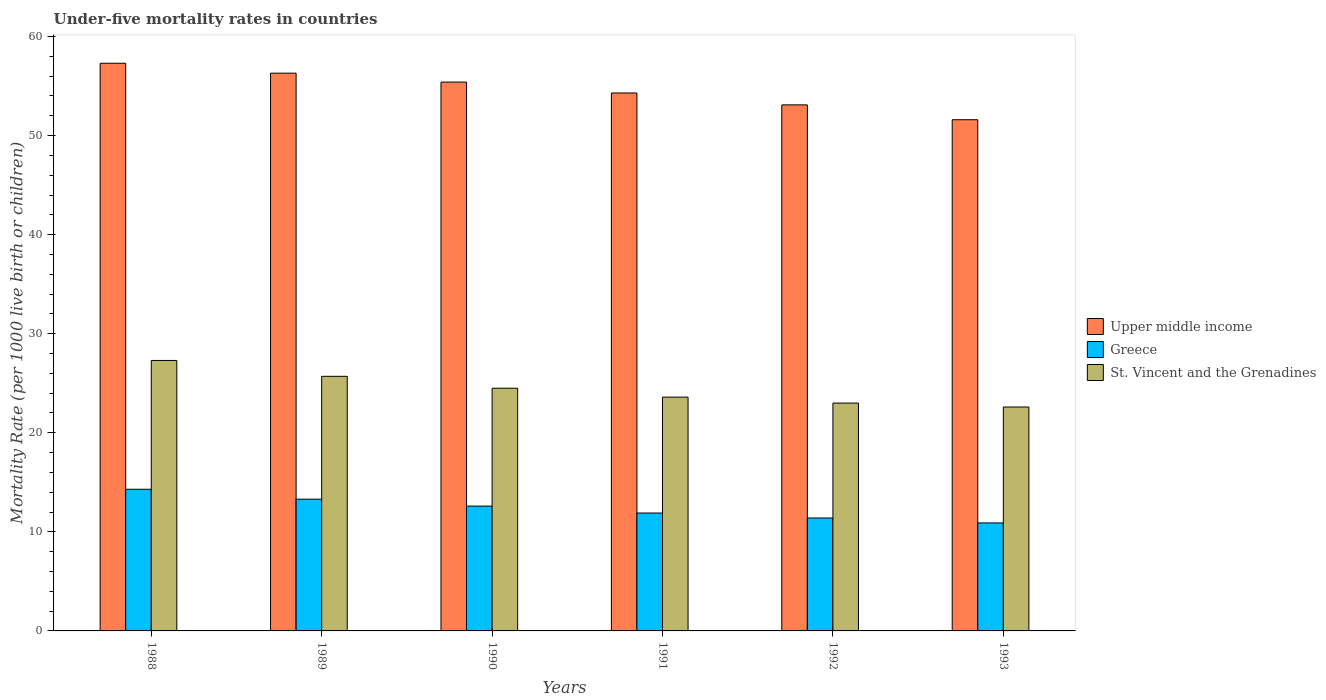How many different coloured bars are there?
Give a very brief answer. 3. How many groups of bars are there?
Your answer should be compact. 6. Are the number of bars on each tick of the X-axis equal?
Make the answer very short. Yes. What is the under-five mortality rate in Upper middle income in 1993?
Your answer should be very brief. 51.6. Across all years, what is the maximum under-five mortality rate in St. Vincent and the Grenadines?
Give a very brief answer. 27.3. Across all years, what is the minimum under-five mortality rate in St. Vincent and the Grenadines?
Provide a short and direct response. 22.6. In which year was the under-five mortality rate in St. Vincent and the Grenadines maximum?
Provide a succinct answer. 1988. In which year was the under-five mortality rate in St. Vincent and the Grenadines minimum?
Your answer should be very brief. 1993. What is the total under-five mortality rate in Greece in the graph?
Your answer should be very brief. 74.4. What is the difference between the under-five mortality rate in St. Vincent and the Grenadines in 1990 and that in 1991?
Ensure brevity in your answer.  0.9. What is the difference between the under-five mortality rate in St. Vincent and the Grenadines in 1991 and the under-five mortality rate in Greece in 1990?
Give a very brief answer. 11. What is the average under-five mortality rate in St. Vincent and the Grenadines per year?
Offer a terse response. 24.45. In how many years, is the under-five mortality rate in St. Vincent and the Grenadines greater than 20?
Ensure brevity in your answer.  6. What is the ratio of the under-five mortality rate in Upper middle income in 1988 to that in 1992?
Provide a succinct answer. 1.08. What is the difference between the highest and the lowest under-five mortality rate in Greece?
Your answer should be very brief. 3.4. What does the 3rd bar from the left in 1990 represents?
Your answer should be very brief. St. Vincent and the Grenadines. What does the 3rd bar from the right in 1990 represents?
Your response must be concise. Upper middle income. How many bars are there?
Your answer should be very brief. 18. How many years are there in the graph?
Your answer should be compact. 6. Does the graph contain grids?
Provide a short and direct response. No. What is the title of the graph?
Offer a very short reply. Under-five mortality rates in countries. Does "Burundi" appear as one of the legend labels in the graph?
Your answer should be very brief. No. What is the label or title of the Y-axis?
Provide a succinct answer. Mortality Rate (per 1000 live birth or children). What is the Mortality Rate (per 1000 live birth or children) of Upper middle income in 1988?
Your response must be concise. 57.3. What is the Mortality Rate (per 1000 live birth or children) of Greece in 1988?
Make the answer very short. 14.3. What is the Mortality Rate (per 1000 live birth or children) of St. Vincent and the Grenadines in 1988?
Give a very brief answer. 27.3. What is the Mortality Rate (per 1000 live birth or children) in Upper middle income in 1989?
Provide a short and direct response. 56.3. What is the Mortality Rate (per 1000 live birth or children) in Greece in 1989?
Give a very brief answer. 13.3. What is the Mortality Rate (per 1000 live birth or children) of St. Vincent and the Grenadines in 1989?
Your response must be concise. 25.7. What is the Mortality Rate (per 1000 live birth or children) of Upper middle income in 1990?
Your answer should be compact. 55.4. What is the Mortality Rate (per 1000 live birth or children) in St. Vincent and the Grenadines in 1990?
Provide a succinct answer. 24.5. What is the Mortality Rate (per 1000 live birth or children) of Upper middle income in 1991?
Offer a terse response. 54.3. What is the Mortality Rate (per 1000 live birth or children) of Greece in 1991?
Provide a succinct answer. 11.9. What is the Mortality Rate (per 1000 live birth or children) of St. Vincent and the Grenadines in 1991?
Provide a short and direct response. 23.6. What is the Mortality Rate (per 1000 live birth or children) of Upper middle income in 1992?
Offer a very short reply. 53.1. What is the Mortality Rate (per 1000 live birth or children) in St. Vincent and the Grenadines in 1992?
Your response must be concise. 23. What is the Mortality Rate (per 1000 live birth or children) of Upper middle income in 1993?
Provide a succinct answer. 51.6. What is the Mortality Rate (per 1000 live birth or children) of St. Vincent and the Grenadines in 1993?
Keep it short and to the point. 22.6. Across all years, what is the maximum Mortality Rate (per 1000 live birth or children) in Upper middle income?
Keep it short and to the point. 57.3. Across all years, what is the maximum Mortality Rate (per 1000 live birth or children) in St. Vincent and the Grenadines?
Your answer should be compact. 27.3. Across all years, what is the minimum Mortality Rate (per 1000 live birth or children) of Upper middle income?
Provide a succinct answer. 51.6. Across all years, what is the minimum Mortality Rate (per 1000 live birth or children) of Greece?
Offer a very short reply. 10.9. Across all years, what is the minimum Mortality Rate (per 1000 live birth or children) in St. Vincent and the Grenadines?
Your answer should be compact. 22.6. What is the total Mortality Rate (per 1000 live birth or children) in Upper middle income in the graph?
Give a very brief answer. 328. What is the total Mortality Rate (per 1000 live birth or children) of Greece in the graph?
Your response must be concise. 74.4. What is the total Mortality Rate (per 1000 live birth or children) in St. Vincent and the Grenadines in the graph?
Make the answer very short. 146.7. What is the difference between the Mortality Rate (per 1000 live birth or children) of Greece in 1988 and that in 1989?
Your response must be concise. 1. What is the difference between the Mortality Rate (per 1000 live birth or children) of St. Vincent and the Grenadines in 1988 and that in 1989?
Your answer should be very brief. 1.6. What is the difference between the Mortality Rate (per 1000 live birth or children) in Upper middle income in 1988 and that in 1990?
Make the answer very short. 1.9. What is the difference between the Mortality Rate (per 1000 live birth or children) in Upper middle income in 1988 and that in 1991?
Your answer should be compact. 3. What is the difference between the Mortality Rate (per 1000 live birth or children) of Greece in 1988 and that in 1991?
Provide a short and direct response. 2.4. What is the difference between the Mortality Rate (per 1000 live birth or children) in Greece in 1988 and that in 1992?
Your response must be concise. 2.9. What is the difference between the Mortality Rate (per 1000 live birth or children) in St. Vincent and the Grenadines in 1988 and that in 1992?
Offer a very short reply. 4.3. What is the difference between the Mortality Rate (per 1000 live birth or children) of Upper middle income in 1988 and that in 1993?
Ensure brevity in your answer.  5.7. What is the difference between the Mortality Rate (per 1000 live birth or children) of Greece in 1988 and that in 1993?
Your response must be concise. 3.4. What is the difference between the Mortality Rate (per 1000 live birth or children) of St. Vincent and the Grenadines in 1988 and that in 1993?
Provide a succinct answer. 4.7. What is the difference between the Mortality Rate (per 1000 live birth or children) in Upper middle income in 1989 and that in 1990?
Offer a terse response. 0.9. What is the difference between the Mortality Rate (per 1000 live birth or children) in Greece in 1989 and that in 1990?
Ensure brevity in your answer.  0.7. What is the difference between the Mortality Rate (per 1000 live birth or children) of Greece in 1989 and that in 1991?
Keep it short and to the point. 1.4. What is the difference between the Mortality Rate (per 1000 live birth or children) of Upper middle income in 1989 and that in 1993?
Your answer should be compact. 4.7. What is the difference between the Mortality Rate (per 1000 live birth or children) of Greece in 1989 and that in 1993?
Keep it short and to the point. 2.4. What is the difference between the Mortality Rate (per 1000 live birth or children) of St. Vincent and the Grenadines in 1989 and that in 1993?
Your response must be concise. 3.1. What is the difference between the Mortality Rate (per 1000 live birth or children) in Upper middle income in 1990 and that in 1991?
Make the answer very short. 1.1. What is the difference between the Mortality Rate (per 1000 live birth or children) in Greece in 1990 and that in 1991?
Give a very brief answer. 0.7. What is the difference between the Mortality Rate (per 1000 live birth or children) of Upper middle income in 1990 and that in 1992?
Provide a succinct answer. 2.3. What is the difference between the Mortality Rate (per 1000 live birth or children) in Greece in 1990 and that in 1992?
Your answer should be compact. 1.2. What is the difference between the Mortality Rate (per 1000 live birth or children) of St. Vincent and the Grenadines in 1990 and that in 1992?
Provide a succinct answer. 1.5. What is the difference between the Mortality Rate (per 1000 live birth or children) of St. Vincent and the Grenadines in 1990 and that in 1993?
Make the answer very short. 1.9. What is the difference between the Mortality Rate (per 1000 live birth or children) in Upper middle income in 1991 and that in 1992?
Offer a terse response. 1.2. What is the difference between the Mortality Rate (per 1000 live birth or children) in Greece in 1991 and that in 1992?
Your response must be concise. 0.5. What is the difference between the Mortality Rate (per 1000 live birth or children) of Upper middle income in 1991 and that in 1993?
Offer a terse response. 2.7. What is the difference between the Mortality Rate (per 1000 live birth or children) in Greece in 1991 and that in 1993?
Your response must be concise. 1. What is the difference between the Mortality Rate (per 1000 live birth or children) in St. Vincent and the Grenadines in 1991 and that in 1993?
Your response must be concise. 1. What is the difference between the Mortality Rate (per 1000 live birth or children) in Upper middle income in 1992 and that in 1993?
Ensure brevity in your answer.  1.5. What is the difference between the Mortality Rate (per 1000 live birth or children) of Greece in 1992 and that in 1993?
Make the answer very short. 0.5. What is the difference between the Mortality Rate (per 1000 live birth or children) in Upper middle income in 1988 and the Mortality Rate (per 1000 live birth or children) in St. Vincent and the Grenadines in 1989?
Offer a terse response. 31.6. What is the difference between the Mortality Rate (per 1000 live birth or children) in Greece in 1988 and the Mortality Rate (per 1000 live birth or children) in St. Vincent and the Grenadines in 1989?
Ensure brevity in your answer.  -11.4. What is the difference between the Mortality Rate (per 1000 live birth or children) of Upper middle income in 1988 and the Mortality Rate (per 1000 live birth or children) of Greece in 1990?
Offer a very short reply. 44.7. What is the difference between the Mortality Rate (per 1000 live birth or children) of Upper middle income in 1988 and the Mortality Rate (per 1000 live birth or children) of St. Vincent and the Grenadines in 1990?
Your answer should be compact. 32.8. What is the difference between the Mortality Rate (per 1000 live birth or children) in Upper middle income in 1988 and the Mortality Rate (per 1000 live birth or children) in Greece in 1991?
Offer a terse response. 45.4. What is the difference between the Mortality Rate (per 1000 live birth or children) in Upper middle income in 1988 and the Mortality Rate (per 1000 live birth or children) in St. Vincent and the Grenadines in 1991?
Your response must be concise. 33.7. What is the difference between the Mortality Rate (per 1000 live birth or children) of Greece in 1988 and the Mortality Rate (per 1000 live birth or children) of St. Vincent and the Grenadines in 1991?
Offer a very short reply. -9.3. What is the difference between the Mortality Rate (per 1000 live birth or children) of Upper middle income in 1988 and the Mortality Rate (per 1000 live birth or children) of Greece in 1992?
Offer a terse response. 45.9. What is the difference between the Mortality Rate (per 1000 live birth or children) of Upper middle income in 1988 and the Mortality Rate (per 1000 live birth or children) of St. Vincent and the Grenadines in 1992?
Make the answer very short. 34.3. What is the difference between the Mortality Rate (per 1000 live birth or children) in Greece in 1988 and the Mortality Rate (per 1000 live birth or children) in St. Vincent and the Grenadines in 1992?
Offer a very short reply. -8.7. What is the difference between the Mortality Rate (per 1000 live birth or children) in Upper middle income in 1988 and the Mortality Rate (per 1000 live birth or children) in Greece in 1993?
Your response must be concise. 46.4. What is the difference between the Mortality Rate (per 1000 live birth or children) in Upper middle income in 1988 and the Mortality Rate (per 1000 live birth or children) in St. Vincent and the Grenadines in 1993?
Your answer should be compact. 34.7. What is the difference between the Mortality Rate (per 1000 live birth or children) of Greece in 1988 and the Mortality Rate (per 1000 live birth or children) of St. Vincent and the Grenadines in 1993?
Give a very brief answer. -8.3. What is the difference between the Mortality Rate (per 1000 live birth or children) of Upper middle income in 1989 and the Mortality Rate (per 1000 live birth or children) of Greece in 1990?
Provide a short and direct response. 43.7. What is the difference between the Mortality Rate (per 1000 live birth or children) of Upper middle income in 1989 and the Mortality Rate (per 1000 live birth or children) of St. Vincent and the Grenadines in 1990?
Your answer should be compact. 31.8. What is the difference between the Mortality Rate (per 1000 live birth or children) of Greece in 1989 and the Mortality Rate (per 1000 live birth or children) of St. Vincent and the Grenadines in 1990?
Offer a very short reply. -11.2. What is the difference between the Mortality Rate (per 1000 live birth or children) of Upper middle income in 1989 and the Mortality Rate (per 1000 live birth or children) of Greece in 1991?
Offer a terse response. 44.4. What is the difference between the Mortality Rate (per 1000 live birth or children) in Upper middle income in 1989 and the Mortality Rate (per 1000 live birth or children) in St. Vincent and the Grenadines in 1991?
Your answer should be very brief. 32.7. What is the difference between the Mortality Rate (per 1000 live birth or children) in Greece in 1989 and the Mortality Rate (per 1000 live birth or children) in St. Vincent and the Grenadines in 1991?
Your answer should be compact. -10.3. What is the difference between the Mortality Rate (per 1000 live birth or children) in Upper middle income in 1989 and the Mortality Rate (per 1000 live birth or children) in Greece in 1992?
Offer a very short reply. 44.9. What is the difference between the Mortality Rate (per 1000 live birth or children) in Upper middle income in 1989 and the Mortality Rate (per 1000 live birth or children) in St. Vincent and the Grenadines in 1992?
Give a very brief answer. 33.3. What is the difference between the Mortality Rate (per 1000 live birth or children) in Greece in 1989 and the Mortality Rate (per 1000 live birth or children) in St. Vincent and the Grenadines in 1992?
Offer a very short reply. -9.7. What is the difference between the Mortality Rate (per 1000 live birth or children) of Upper middle income in 1989 and the Mortality Rate (per 1000 live birth or children) of Greece in 1993?
Provide a short and direct response. 45.4. What is the difference between the Mortality Rate (per 1000 live birth or children) in Upper middle income in 1989 and the Mortality Rate (per 1000 live birth or children) in St. Vincent and the Grenadines in 1993?
Provide a succinct answer. 33.7. What is the difference between the Mortality Rate (per 1000 live birth or children) in Upper middle income in 1990 and the Mortality Rate (per 1000 live birth or children) in Greece in 1991?
Keep it short and to the point. 43.5. What is the difference between the Mortality Rate (per 1000 live birth or children) in Upper middle income in 1990 and the Mortality Rate (per 1000 live birth or children) in St. Vincent and the Grenadines in 1991?
Make the answer very short. 31.8. What is the difference between the Mortality Rate (per 1000 live birth or children) of Upper middle income in 1990 and the Mortality Rate (per 1000 live birth or children) of St. Vincent and the Grenadines in 1992?
Your response must be concise. 32.4. What is the difference between the Mortality Rate (per 1000 live birth or children) in Greece in 1990 and the Mortality Rate (per 1000 live birth or children) in St. Vincent and the Grenadines in 1992?
Offer a very short reply. -10.4. What is the difference between the Mortality Rate (per 1000 live birth or children) of Upper middle income in 1990 and the Mortality Rate (per 1000 live birth or children) of Greece in 1993?
Offer a terse response. 44.5. What is the difference between the Mortality Rate (per 1000 live birth or children) in Upper middle income in 1990 and the Mortality Rate (per 1000 live birth or children) in St. Vincent and the Grenadines in 1993?
Your answer should be very brief. 32.8. What is the difference between the Mortality Rate (per 1000 live birth or children) in Greece in 1990 and the Mortality Rate (per 1000 live birth or children) in St. Vincent and the Grenadines in 1993?
Give a very brief answer. -10. What is the difference between the Mortality Rate (per 1000 live birth or children) of Upper middle income in 1991 and the Mortality Rate (per 1000 live birth or children) of Greece in 1992?
Your answer should be compact. 42.9. What is the difference between the Mortality Rate (per 1000 live birth or children) in Upper middle income in 1991 and the Mortality Rate (per 1000 live birth or children) in St. Vincent and the Grenadines in 1992?
Offer a terse response. 31.3. What is the difference between the Mortality Rate (per 1000 live birth or children) in Greece in 1991 and the Mortality Rate (per 1000 live birth or children) in St. Vincent and the Grenadines in 1992?
Ensure brevity in your answer.  -11.1. What is the difference between the Mortality Rate (per 1000 live birth or children) of Upper middle income in 1991 and the Mortality Rate (per 1000 live birth or children) of Greece in 1993?
Give a very brief answer. 43.4. What is the difference between the Mortality Rate (per 1000 live birth or children) of Upper middle income in 1991 and the Mortality Rate (per 1000 live birth or children) of St. Vincent and the Grenadines in 1993?
Make the answer very short. 31.7. What is the difference between the Mortality Rate (per 1000 live birth or children) in Upper middle income in 1992 and the Mortality Rate (per 1000 live birth or children) in Greece in 1993?
Make the answer very short. 42.2. What is the difference between the Mortality Rate (per 1000 live birth or children) in Upper middle income in 1992 and the Mortality Rate (per 1000 live birth or children) in St. Vincent and the Grenadines in 1993?
Make the answer very short. 30.5. What is the difference between the Mortality Rate (per 1000 live birth or children) in Greece in 1992 and the Mortality Rate (per 1000 live birth or children) in St. Vincent and the Grenadines in 1993?
Provide a short and direct response. -11.2. What is the average Mortality Rate (per 1000 live birth or children) in Upper middle income per year?
Your answer should be very brief. 54.67. What is the average Mortality Rate (per 1000 live birth or children) of St. Vincent and the Grenadines per year?
Provide a succinct answer. 24.45. In the year 1988, what is the difference between the Mortality Rate (per 1000 live birth or children) in Upper middle income and Mortality Rate (per 1000 live birth or children) in St. Vincent and the Grenadines?
Your answer should be very brief. 30. In the year 1989, what is the difference between the Mortality Rate (per 1000 live birth or children) of Upper middle income and Mortality Rate (per 1000 live birth or children) of Greece?
Offer a very short reply. 43. In the year 1989, what is the difference between the Mortality Rate (per 1000 live birth or children) in Upper middle income and Mortality Rate (per 1000 live birth or children) in St. Vincent and the Grenadines?
Your response must be concise. 30.6. In the year 1990, what is the difference between the Mortality Rate (per 1000 live birth or children) of Upper middle income and Mortality Rate (per 1000 live birth or children) of Greece?
Offer a very short reply. 42.8. In the year 1990, what is the difference between the Mortality Rate (per 1000 live birth or children) in Upper middle income and Mortality Rate (per 1000 live birth or children) in St. Vincent and the Grenadines?
Provide a succinct answer. 30.9. In the year 1991, what is the difference between the Mortality Rate (per 1000 live birth or children) of Upper middle income and Mortality Rate (per 1000 live birth or children) of Greece?
Give a very brief answer. 42.4. In the year 1991, what is the difference between the Mortality Rate (per 1000 live birth or children) in Upper middle income and Mortality Rate (per 1000 live birth or children) in St. Vincent and the Grenadines?
Provide a succinct answer. 30.7. In the year 1991, what is the difference between the Mortality Rate (per 1000 live birth or children) of Greece and Mortality Rate (per 1000 live birth or children) of St. Vincent and the Grenadines?
Your answer should be very brief. -11.7. In the year 1992, what is the difference between the Mortality Rate (per 1000 live birth or children) of Upper middle income and Mortality Rate (per 1000 live birth or children) of Greece?
Make the answer very short. 41.7. In the year 1992, what is the difference between the Mortality Rate (per 1000 live birth or children) of Upper middle income and Mortality Rate (per 1000 live birth or children) of St. Vincent and the Grenadines?
Make the answer very short. 30.1. In the year 1993, what is the difference between the Mortality Rate (per 1000 live birth or children) in Upper middle income and Mortality Rate (per 1000 live birth or children) in Greece?
Your response must be concise. 40.7. In the year 1993, what is the difference between the Mortality Rate (per 1000 live birth or children) of Upper middle income and Mortality Rate (per 1000 live birth or children) of St. Vincent and the Grenadines?
Provide a succinct answer. 29. In the year 1993, what is the difference between the Mortality Rate (per 1000 live birth or children) of Greece and Mortality Rate (per 1000 live birth or children) of St. Vincent and the Grenadines?
Offer a terse response. -11.7. What is the ratio of the Mortality Rate (per 1000 live birth or children) in Upper middle income in 1988 to that in 1989?
Your answer should be compact. 1.02. What is the ratio of the Mortality Rate (per 1000 live birth or children) in Greece in 1988 to that in 1989?
Offer a terse response. 1.08. What is the ratio of the Mortality Rate (per 1000 live birth or children) of St. Vincent and the Grenadines in 1988 to that in 1989?
Make the answer very short. 1.06. What is the ratio of the Mortality Rate (per 1000 live birth or children) of Upper middle income in 1988 to that in 1990?
Your answer should be compact. 1.03. What is the ratio of the Mortality Rate (per 1000 live birth or children) of Greece in 1988 to that in 1990?
Provide a short and direct response. 1.13. What is the ratio of the Mortality Rate (per 1000 live birth or children) in St. Vincent and the Grenadines in 1988 to that in 1990?
Provide a short and direct response. 1.11. What is the ratio of the Mortality Rate (per 1000 live birth or children) of Upper middle income in 1988 to that in 1991?
Give a very brief answer. 1.06. What is the ratio of the Mortality Rate (per 1000 live birth or children) of Greece in 1988 to that in 1991?
Keep it short and to the point. 1.2. What is the ratio of the Mortality Rate (per 1000 live birth or children) in St. Vincent and the Grenadines in 1988 to that in 1991?
Provide a short and direct response. 1.16. What is the ratio of the Mortality Rate (per 1000 live birth or children) in Upper middle income in 1988 to that in 1992?
Give a very brief answer. 1.08. What is the ratio of the Mortality Rate (per 1000 live birth or children) in Greece in 1988 to that in 1992?
Provide a short and direct response. 1.25. What is the ratio of the Mortality Rate (per 1000 live birth or children) in St. Vincent and the Grenadines in 1988 to that in 1992?
Provide a succinct answer. 1.19. What is the ratio of the Mortality Rate (per 1000 live birth or children) in Upper middle income in 1988 to that in 1993?
Offer a terse response. 1.11. What is the ratio of the Mortality Rate (per 1000 live birth or children) in Greece in 1988 to that in 1993?
Keep it short and to the point. 1.31. What is the ratio of the Mortality Rate (per 1000 live birth or children) of St. Vincent and the Grenadines in 1988 to that in 1993?
Your answer should be compact. 1.21. What is the ratio of the Mortality Rate (per 1000 live birth or children) in Upper middle income in 1989 to that in 1990?
Ensure brevity in your answer.  1.02. What is the ratio of the Mortality Rate (per 1000 live birth or children) in Greece in 1989 to that in 1990?
Offer a very short reply. 1.06. What is the ratio of the Mortality Rate (per 1000 live birth or children) of St. Vincent and the Grenadines in 1989 to that in 1990?
Your answer should be very brief. 1.05. What is the ratio of the Mortality Rate (per 1000 live birth or children) in Upper middle income in 1989 to that in 1991?
Your answer should be compact. 1.04. What is the ratio of the Mortality Rate (per 1000 live birth or children) of Greece in 1989 to that in 1991?
Provide a short and direct response. 1.12. What is the ratio of the Mortality Rate (per 1000 live birth or children) of St. Vincent and the Grenadines in 1989 to that in 1991?
Your response must be concise. 1.09. What is the ratio of the Mortality Rate (per 1000 live birth or children) of Upper middle income in 1989 to that in 1992?
Keep it short and to the point. 1.06. What is the ratio of the Mortality Rate (per 1000 live birth or children) in Greece in 1989 to that in 1992?
Your answer should be compact. 1.17. What is the ratio of the Mortality Rate (per 1000 live birth or children) in St. Vincent and the Grenadines in 1989 to that in 1992?
Your response must be concise. 1.12. What is the ratio of the Mortality Rate (per 1000 live birth or children) of Upper middle income in 1989 to that in 1993?
Provide a succinct answer. 1.09. What is the ratio of the Mortality Rate (per 1000 live birth or children) of Greece in 1989 to that in 1993?
Your response must be concise. 1.22. What is the ratio of the Mortality Rate (per 1000 live birth or children) in St. Vincent and the Grenadines in 1989 to that in 1993?
Keep it short and to the point. 1.14. What is the ratio of the Mortality Rate (per 1000 live birth or children) of Upper middle income in 1990 to that in 1991?
Offer a very short reply. 1.02. What is the ratio of the Mortality Rate (per 1000 live birth or children) of Greece in 1990 to that in 1991?
Your answer should be very brief. 1.06. What is the ratio of the Mortality Rate (per 1000 live birth or children) in St. Vincent and the Grenadines in 1990 to that in 1991?
Provide a succinct answer. 1.04. What is the ratio of the Mortality Rate (per 1000 live birth or children) of Upper middle income in 1990 to that in 1992?
Make the answer very short. 1.04. What is the ratio of the Mortality Rate (per 1000 live birth or children) of Greece in 1990 to that in 1992?
Keep it short and to the point. 1.11. What is the ratio of the Mortality Rate (per 1000 live birth or children) in St. Vincent and the Grenadines in 1990 to that in 1992?
Provide a succinct answer. 1.07. What is the ratio of the Mortality Rate (per 1000 live birth or children) of Upper middle income in 1990 to that in 1993?
Keep it short and to the point. 1.07. What is the ratio of the Mortality Rate (per 1000 live birth or children) in Greece in 1990 to that in 1993?
Your answer should be compact. 1.16. What is the ratio of the Mortality Rate (per 1000 live birth or children) in St. Vincent and the Grenadines in 1990 to that in 1993?
Provide a succinct answer. 1.08. What is the ratio of the Mortality Rate (per 1000 live birth or children) in Upper middle income in 1991 to that in 1992?
Your answer should be very brief. 1.02. What is the ratio of the Mortality Rate (per 1000 live birth or children) in Greece in 1991 to that in 1992?
Your response must be concise. 1.04. What is the ratio of the Mortality Rate (per 1000 live birth or children) of St. Vincent and the Grenadines in 1991 to that in 1992?
Give a very brief answer. 1.03. What is the ratio of the Mortality Rate (per 1000 live birth or children) of Upper middle income in 1991 to that in 1993?
Your response must be concise. 1.05. What is the ratio of the Mortality Rate (per 1000 live birth or children) in Greece in 1991 to that in 1993?
Your answer should be very brief. 1.09. What is the ratio of the Mortality Rate (per 1000 live birth or children) in St. Vincent and the Grenadines in 1991 to that in 1993?
Offer a terse response. 1.04. What is the ratio of the Mortality Rate (per 1000 live birth or children) of Upper middle income in 1992 to that in 1993?
Offer a very short reply. 1.03. What is the ratio of the Mortality Rate (per 1000 live birth or children) of Greece in 1992 to that in 1993?
Your response must be concise. 1.05. What is the ratio of the Mortality Rate (per 1000 live birth or children) in St. Vincent and the Grenadines in 1992 to that in 1993?
Offer a very short reply. 1.02. What is the difference between the highest and the second highest Mortality Rate (per 1000 live birth or children) of Upper middle income?
Provide a short and direct response. 1. What is the difference between the highest and the second highest Mortality Rate (per 1000 live birth or children) of Greece?
Ensure brevity in your answer.  1. What is the difference between the highest and the second highest Mortality Rate (per 1000 live birth or children) of St. Vincent and the Grenadines?
Your response must be concise. 1.6. What is the difference between the highest and the lowest Mortality Rate (per 1000 live birth or children) of Upper middle income?
Keep it short and to the point. 5.7. 